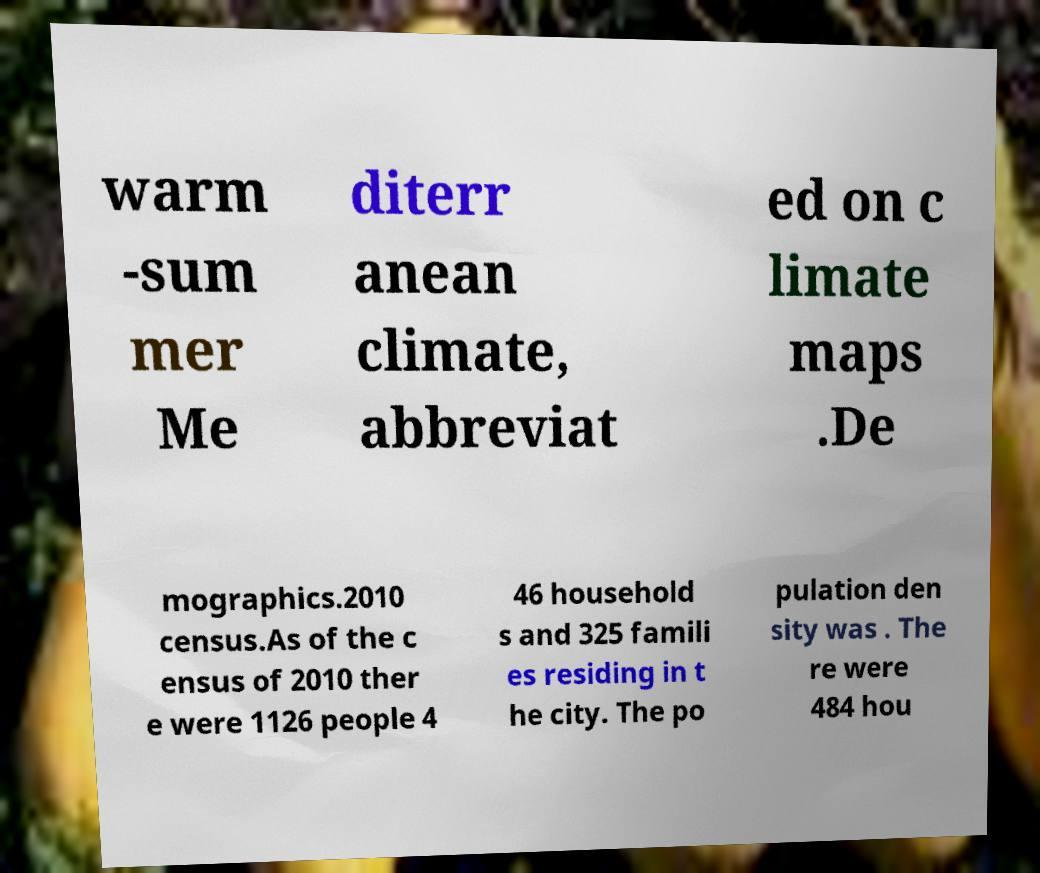Could you extract and type out the text from this image? warm -sum mer Me diterr anean climate, abbreviat ed on c limate maps .De mographics.2010 census.As of the c ensus of 2010 ther e were 1126 people 4 46 household s and 325 famili es residing in t he city. The po pulation den sity was . The re were 484 hou 